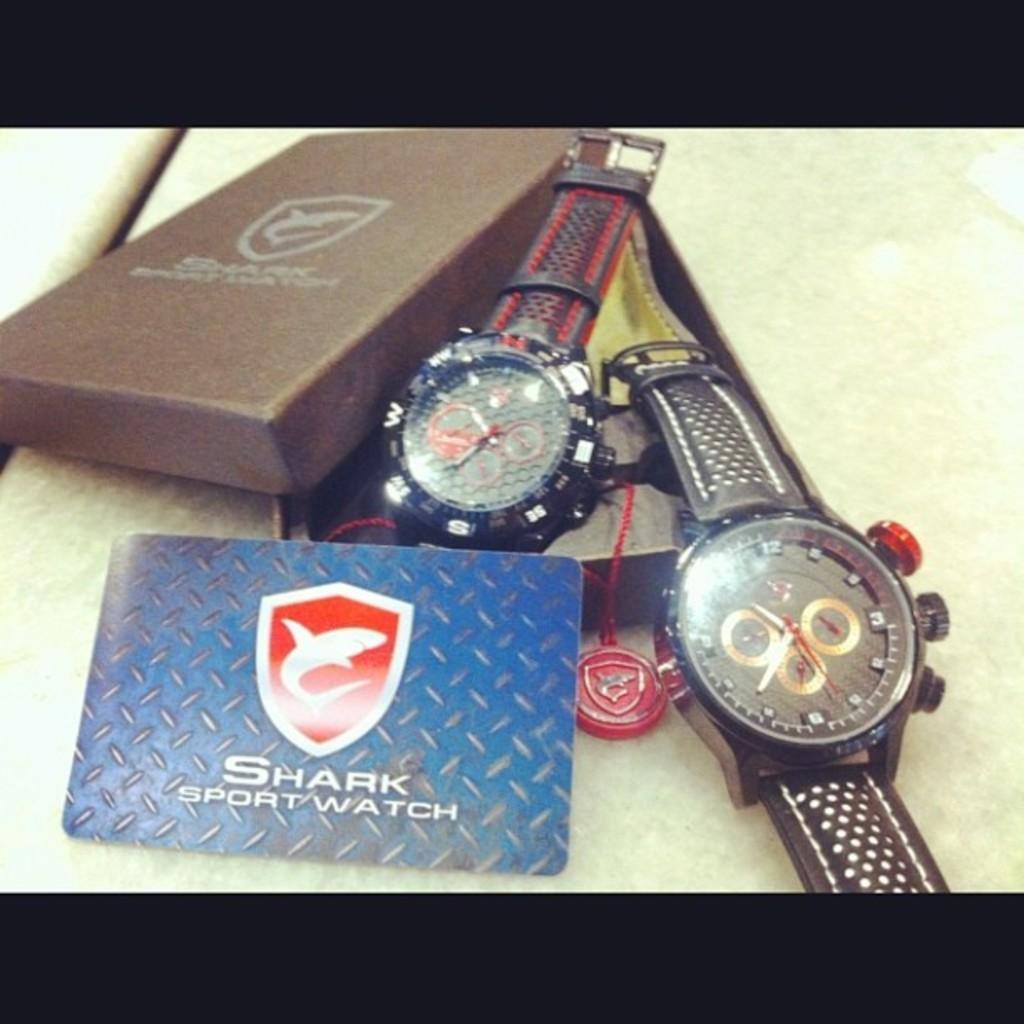<image>
Create a compact narrative representing the image presented. Two Shark sport watch with the box laying flat 